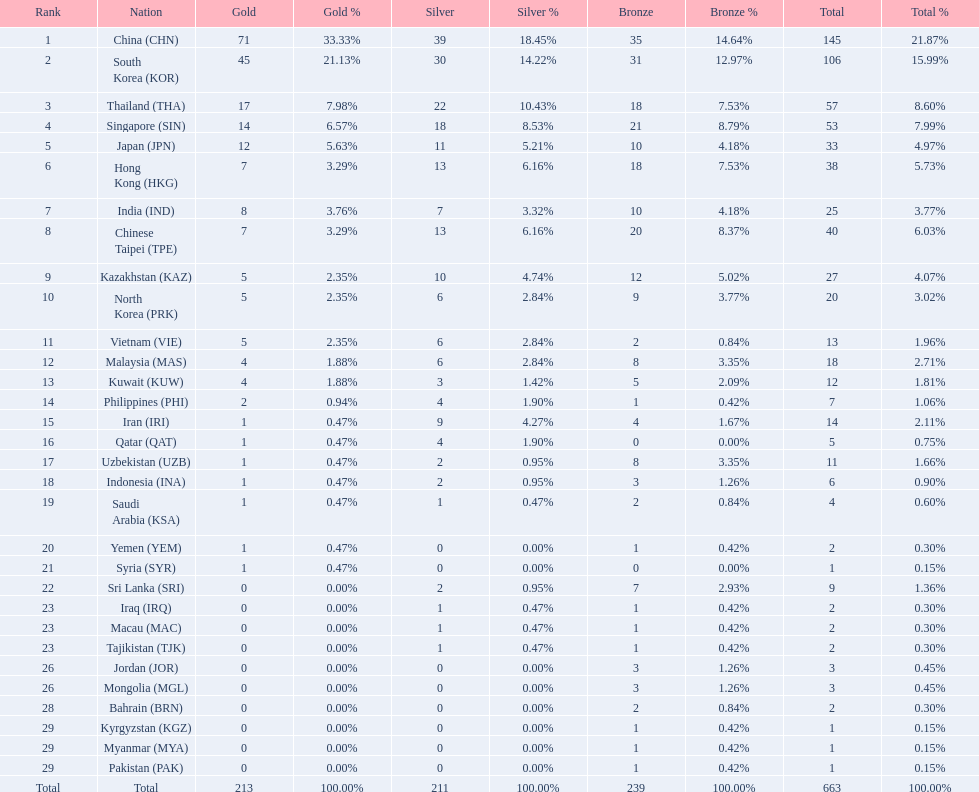How many countries have at least 10 gold medals in the asian youth games? 5. 